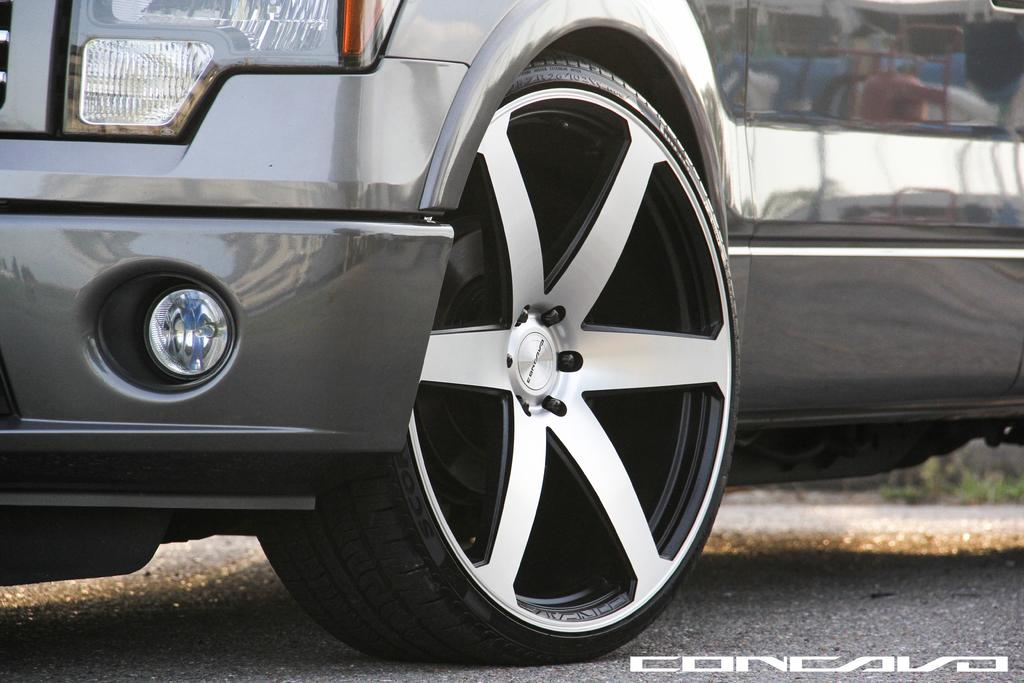What is the main subject of the picture? The main subject of the picture is a vehicle. Can you describe a specific part of the vehicle that is visible? The tire of the vehicle is visible in the middle of the picture. Where can text be found in the picture? There is text in the bottom right side of the picture. What type of book is the family reading while driving in the picture? There is no book or family present in the picture, and no driving is depicted. 